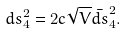<formula> <loc_0><loc_0><loc_500><loc_500>d s _ { 4 } ^ { 2 } = 2 c \sqrt { V } \bar { d s } _ { 4 } ^ { 2 } .</formula> 